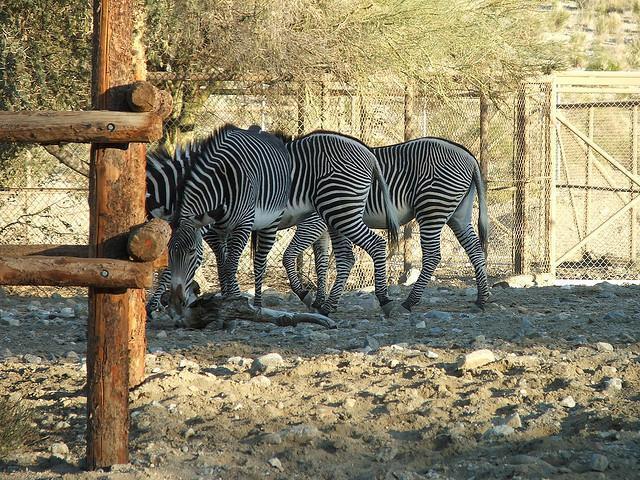How many zebras are in the picture?
Give a very brief answer. 3. 